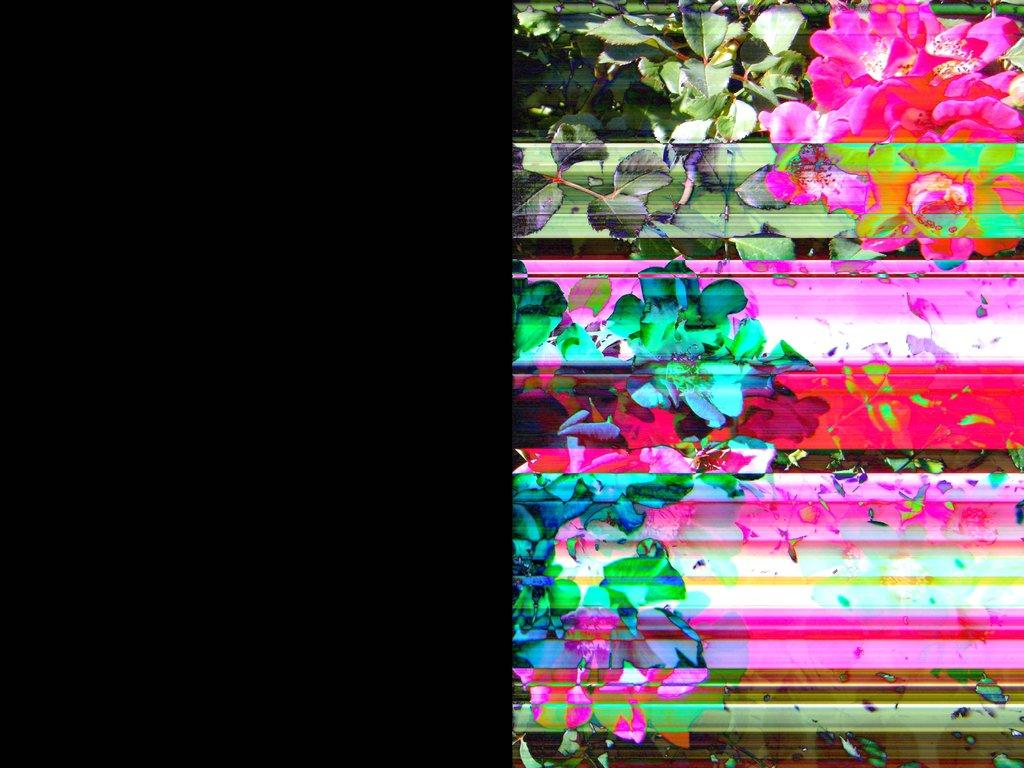What can be observed about the lighting on the left side of the image? The left side of the image is dark. What types of vegetation are present in the image? There are plants and flowers in the image. Can you describe the specific floral elements in the image? Unfortunately, based on the provided facts, we cannot accurately describe the flowers in the image. What type of board game is being played in the image? There is no board game present in the image. How much does the dime cost in the image? There is no dime present in the image. 